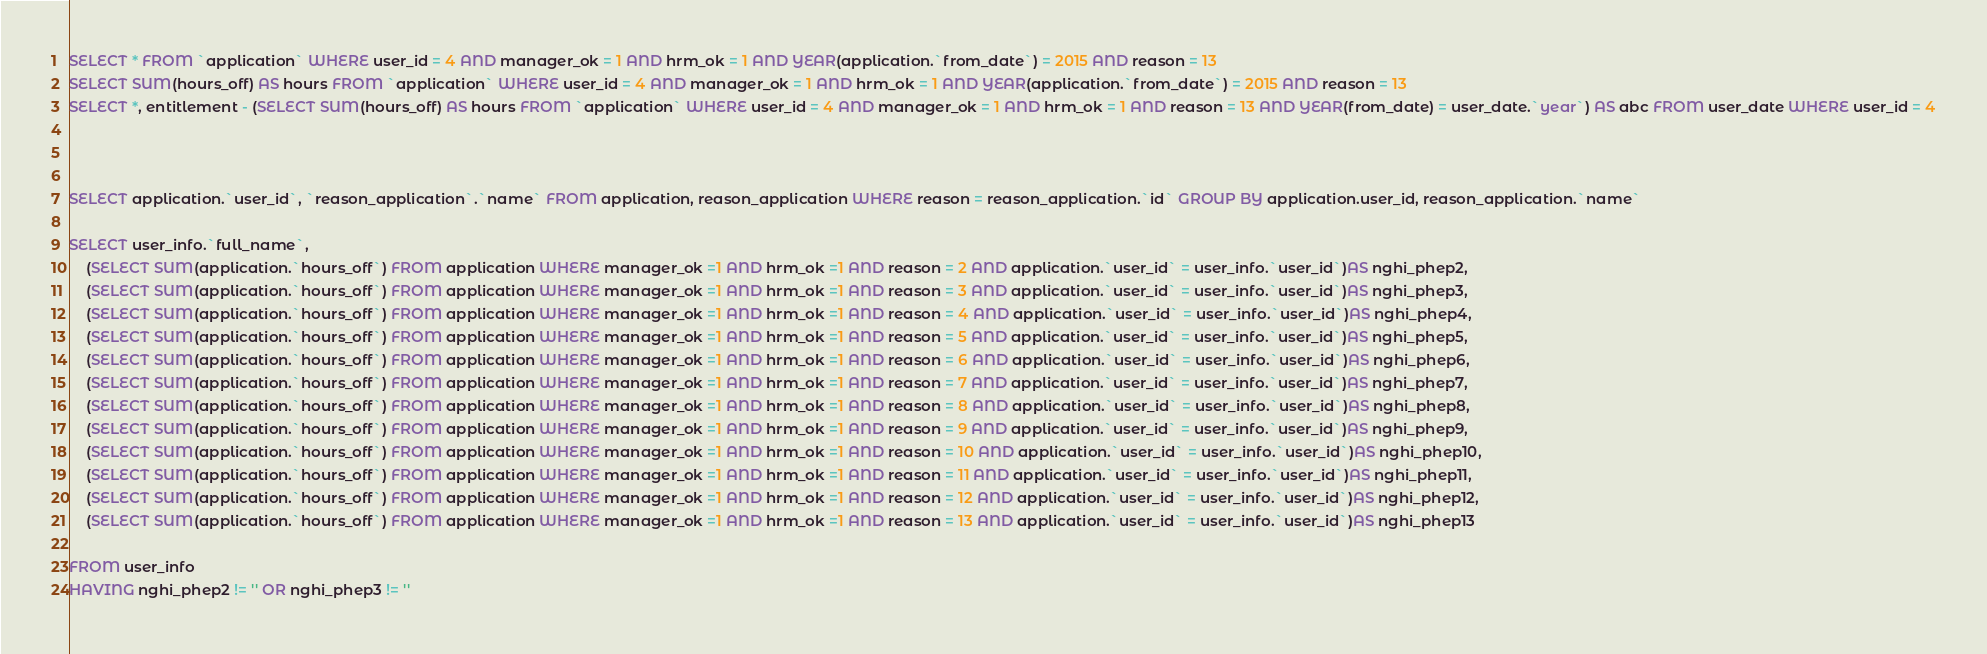Convert code to text. <code><loc_0><loc_0><loc_500><loc_500><_SQL_>SELECT * FROM `application` WHERE user_id = 4 AND manager_ok = 1 AND hrm_ok = 1 AND YEAR(application.`from_date`) = 2015 AND reason = 13
SELECT SUM(hours_off) AS hours FROM `application` WHERE user_id = 4 AND manager_ok = 1 AND hrm_ok = 1 AND YEAR(application.`from_date`) = 2015 AND reason = 13
SELECT *, entitlement - (SELECT SUM(hours_off) AS hours FROM `application` WHERE user_id = 4 AND manager_ok = 1 AND hrm_ok = 1 AND reason = 13 AND YEAR(from_date) = user_date.`year`) AS abc FROM user_date WHERE user_id = 4



SELECT application.`user_id`, `reason_application`.`name` FROM application, reason_application WHERE reason = reason_application.`id` GROUP BY application.user_id, reason_application.`name`

SELECT user_info.`full_name`, 
	(SELECT SUM(application.`hours_off`) FROM application WHERE manager_ok =1 AND hrm_ok =1 AND reason = 2 AND application.`user_id` = user_info.`user_id`)AS nghi_phep2,
	(SELECT SUM(application.`hours_off`) FROM application WHERE manager_ok =1 AND hrm_ok =1 AND reason = 3 AND application.`user_id` = user_info.`user_id`)AS nghi_phep3,
	(SELECT SUM(application.`hours_off`) FROM application WHERE manager_ok =1 AND hrm_ok =1 AND reason = 4 AND application.`user_id` = user_info.`user_id`)AS nghi_phep4,
	(SELECT SUM(application.`hours_off`) FROM application WHERE manager_ok =1 AND hrm_ok =1 AND reason = 5 AND application.`user_id` = user_info.`user_id`)AS nghi_phep5,
	(SELECT SUM(application.`hours_off`) FROM application WHERE manager_ok =1 AND hrm_ok =1 AND reason = 6 AND application.`user_id` = user_info.`user_id`)AS nghi_phep6,
	(SELECT SUM(application.`hours_off`) FROM application WHERE manager_ok =1 AND hrm_ok =1 AND reason = 7 AND application.`user_id` = user_info.`user_id`)AS nghi_phep7,
	(SELECT SUM(application.`hours_off`) FROM application WHERE manager_ok =1 AND hrm_ok =1 AND reason = 8 AND application.`user_id` = user_info.`user_id`)AS nghi_phep8,
	(SELECT SUM(application.`hours_off`) FROM application WHERE manager_ok =1 AND hrm_ok =1 AND reason = 9 AND application.`user_id` = user_info.`user_id`)AS nghi_phep9,
	(SELECT SUM(application.`hours_off`) FROM application WHERE manager_ok =1 AND hrm_ok =1 AND reason = 10 AND application.`user_id` = user_info.`user_id`)AS nghi_phep10,
	(SELECT SUM(application.`hours_off`) FROM application WHERE manager_ok =1 AND hrm_ok =1 AND reason = 11 AND application.`user_id` = user_info.`user_id`)AS nghi_phep11,
	(SELECT SUM(application.`hours_off`) FROM application WHERE manager_ok =1 AND hrm_ok =1 AND reason = 12 AND application.`user_id` = user_info.`user_id`)AS nghi_phep12,
	(SELECT SUM(application.`hours_off`) FROM application WHERE manager_ok =1 AND hrm_ok =1 AND reason = 13 AND application.`user_id` = user_info.`user_id`)AS nghi_phep13
	
FROM user_info
HAVING nghi_phep2 != '' OR nghi_phep3 != ''</code> 